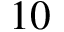<formula> <loc_0><loc_0><loc_500><loc_500>1 0</formula> 